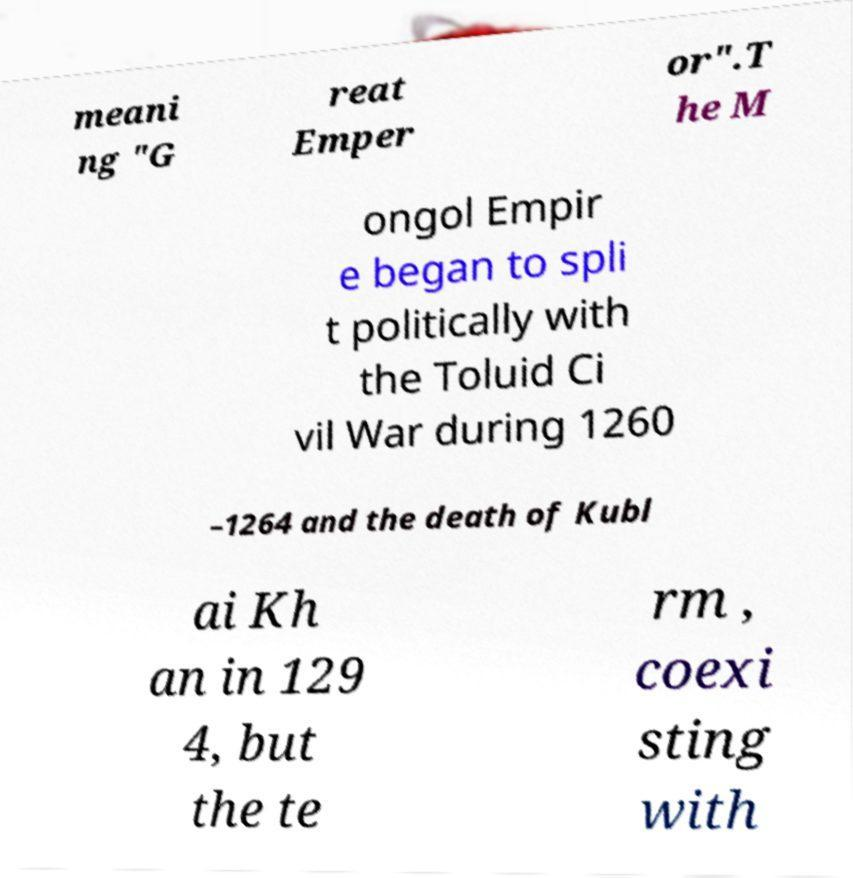Please read and relay the text visible in this image. What does it say? meani ng "G reat Emper or".T he M ongol Empir e began to spli t politically with the Toluid Ci vil War during 1260 –1264 and the death of Kubl ai Kh an in 129 4, but the te rm , coexi sting with 